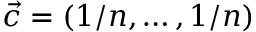<formula> <loc_0><loc_0><loc_500><loc_500>\vec { c } = ( 1 / n , \dots , 1 / n )</formula> 